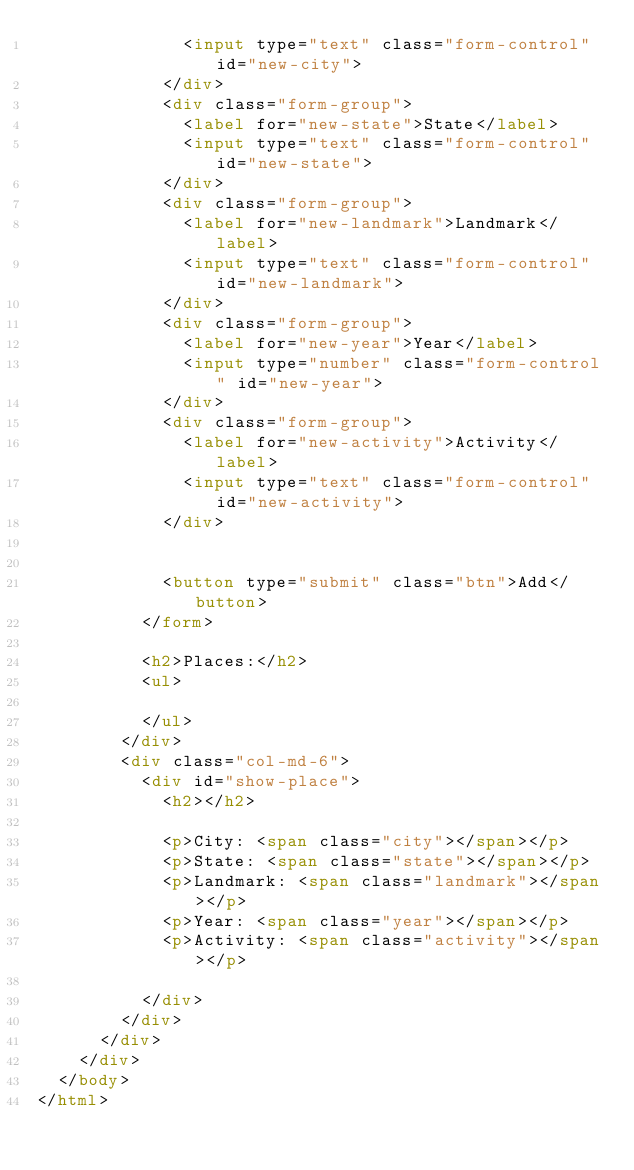Convert code to text. <code><loc_0><loc_0><loc_500><loc_500><_HTML_>              <input type="text" class="form-control" id="new-city">
            </div>
            <div class="form-group">
              <label for="new-state">State</label>
              <input type="text" class="form-control" id="new-state">
            </div>
            <div class="form-group">
              <label for="new-landmark">Landmark</label>
              <input type="text" class="form-control" id="new-landmark">
            </div>
            <div class="form-group">
              <label for="new-year">Year</label>
              <input type="number" class="form-control" id="new-year">
            </div>
            <div class="form-group">
              <label for="new-activity">Activity</label>
              <input type="text" class="form-control" id="new-activity">
            </div>


            <button type="submit" class="btn">Add</button>
          </form>

          <h2>Places:</h2>
          <ul>

          </ul>
        </div>
        <div class="col-md-6">
          <div id="show-place">
            <h2></h2>

            <p>City: <span class="city"></span></p>
            <p>State: <span class="state"></span></p>
            <p>Landmark: <span class="landmark"></span></p>
            <p>Year: <span class="year"></span></p>
            <p>Activity: <span class="activity"></span></p>

          </div>
        </div>
      </div>
    </div>
  </body>
</html>
</code> 